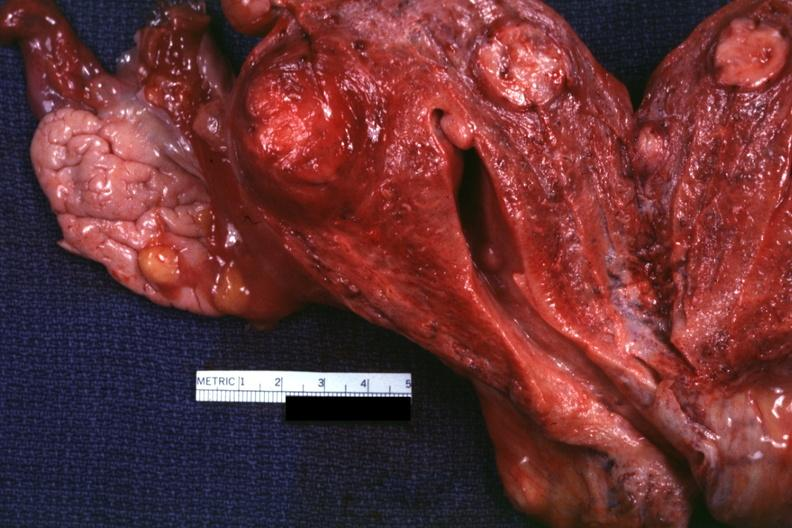what is present?
Answer the question using a single word or phrase. Female reproductive 